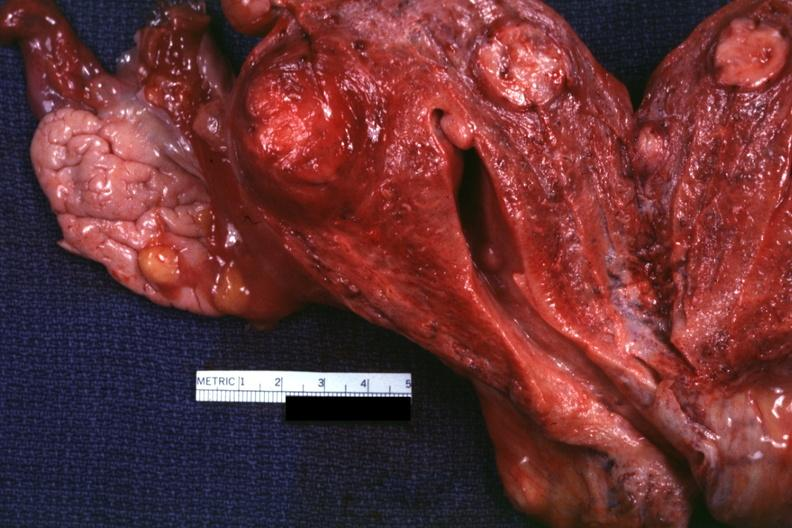what is present?
Answer the question using a single word or phrase. Female reproductive 